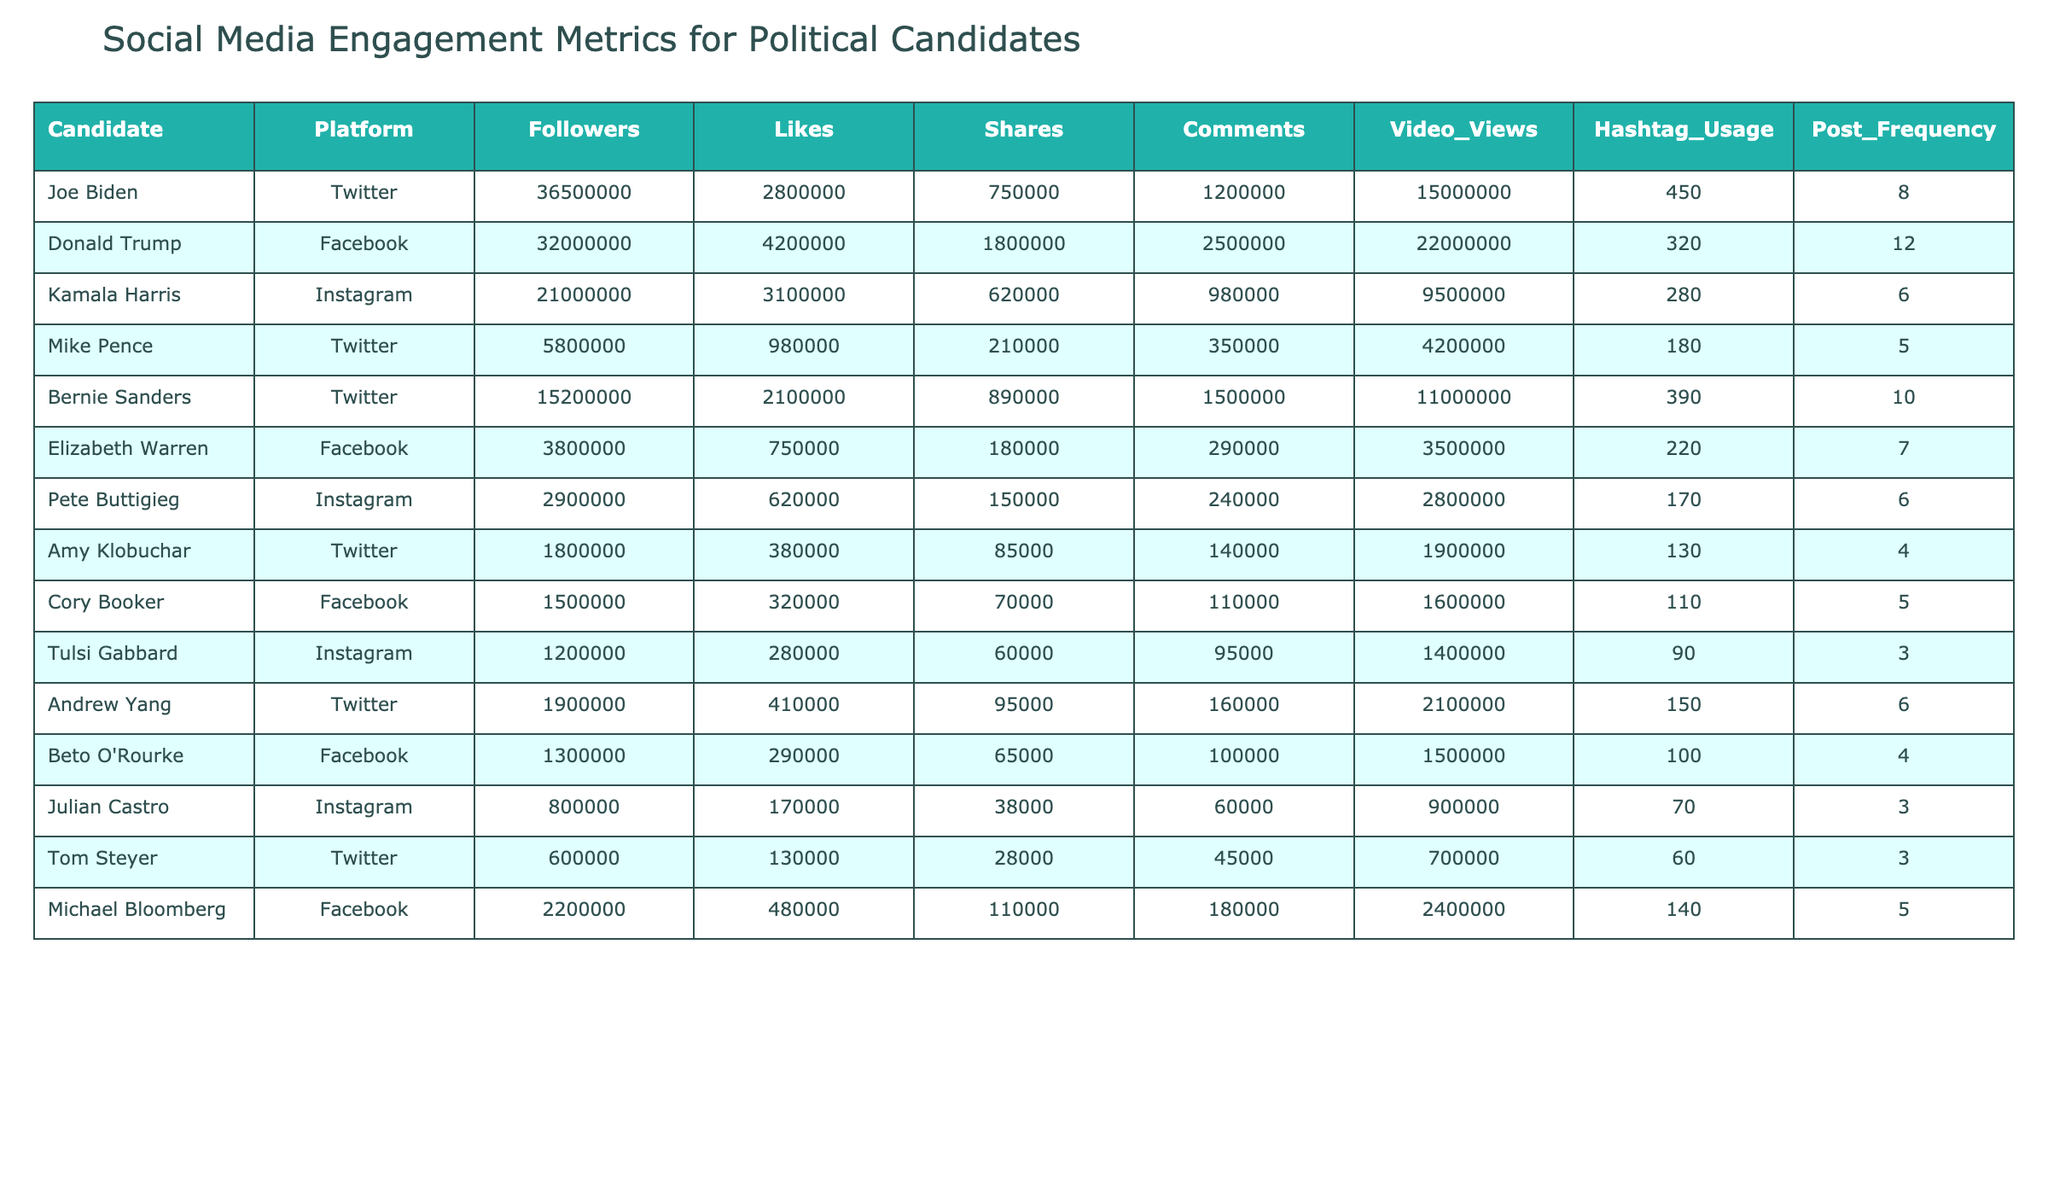What is the total number of followers for all candidates on Twitter? Joe Biden has 36,500,000 followers, Mike Pence has 5,800,000, Bernie Sanders has 15,200,000, and Amy Klobuchar has 1,800,000. Therefore, total followers on Twitter = 36,500,000 + 5,800,000 + 15,200,000 + 1,800,000 = 59,300,000.
Answer: 59,300,000 Which candidate had the highest number of likes on Facebook? Donald Trump has 4,200,000 likes and is the only candidate on Facebook with more than 4 million likes, making him the highest on this platform.
Answer: Donald Trump What platform did Kamala Harris use for engagement? The table indicates that Kamala Harris is engaged on Instagram.
Answer: Instagram What is the average number of comments from candidates on Instagram? Kamala Harris has 980,000 comments, Pete Buttigieg has 240,000, and Tulsi Gabbard has 95,000. Therefore, average comments on Instagram = (980,000 + 240,000 + 95,000) / 3 = 438,333.33, approximately 438,333.
Answer: 438,333 Is it true that Andrew Yang had more video views than Michael Bloomberg? Andrew Yang has 2,100,000 video views while Michael Bloomberg has 2,400,000. Since 2,100,000 is less than 2,400,000, it is false.
Answer: False Which Twitter candidate had the least post frequency? Among the Twitter candidates, Amy Klobuchar has the least post frequency with 4 posts.
Answer: Amy Klobuchar How do the total likes for candidates on Facebook compare to those on Twitter? Facebook candidates (Donald Trump, Elizabeth Warren, Cory Booker, and Michael Bloomberg) total likes = 4,200,000 + 750,000 + 320,000 + 480,000 = 5,750,000. Twitter candidates total likes = 2,800,000 + 980,000 + 2,100,000 + 380,000 = 6,260,000. Since 6,260,000 is greater than 5,750,000, Twitter has more likes.
Answer: Twitter has more likes Identify the candidate with the most post frequency on Facebook. Donald Trump has the highest post frequency with 12 posts on Facebook.
Answer: Donald Trump What candidate on Instagram had the highest video views? Kamala Harris has 9,500,000 video views, which is higher than Pete Buttigieg's 2,800,000 and Tulsi Gabbard's 1,400,000.
Answer: Kamala Harris Was the total hashtag usage by Joe Biden more than that of Amy Klobuchar? Joe Biden has 450 hashtag usages while Amy Klobuchar has 130. Since 450 is greater than 130, it is true.
Answer: True 